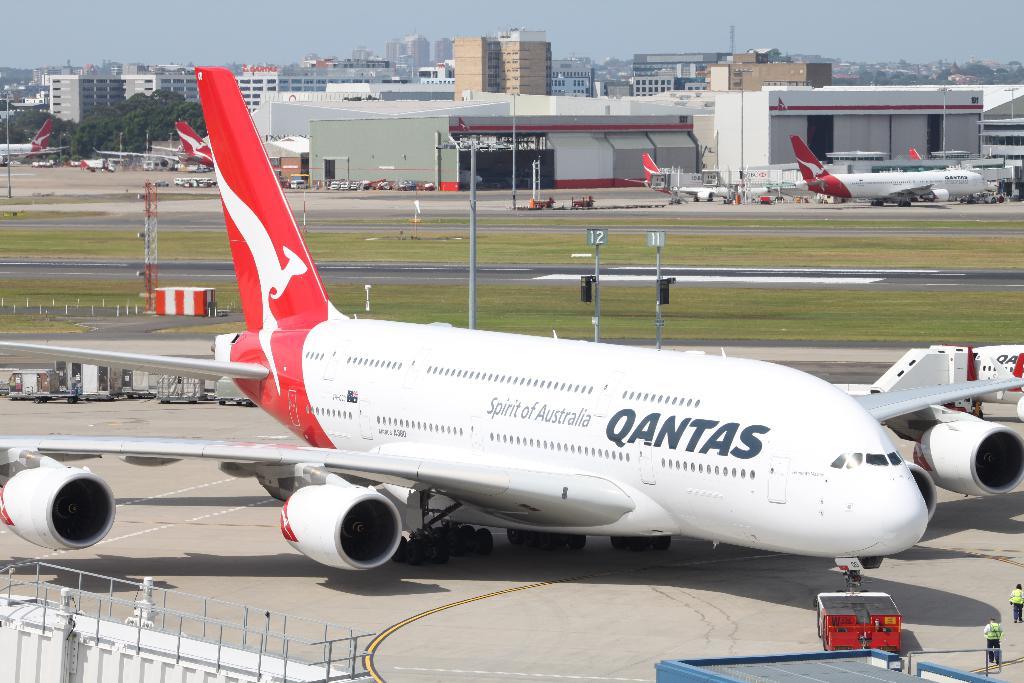What airline does that plane belong to?
Keep it short and to the point. Qantas. What is the big word on the plane?
Ensure brevity in your answer.  Qantas. 